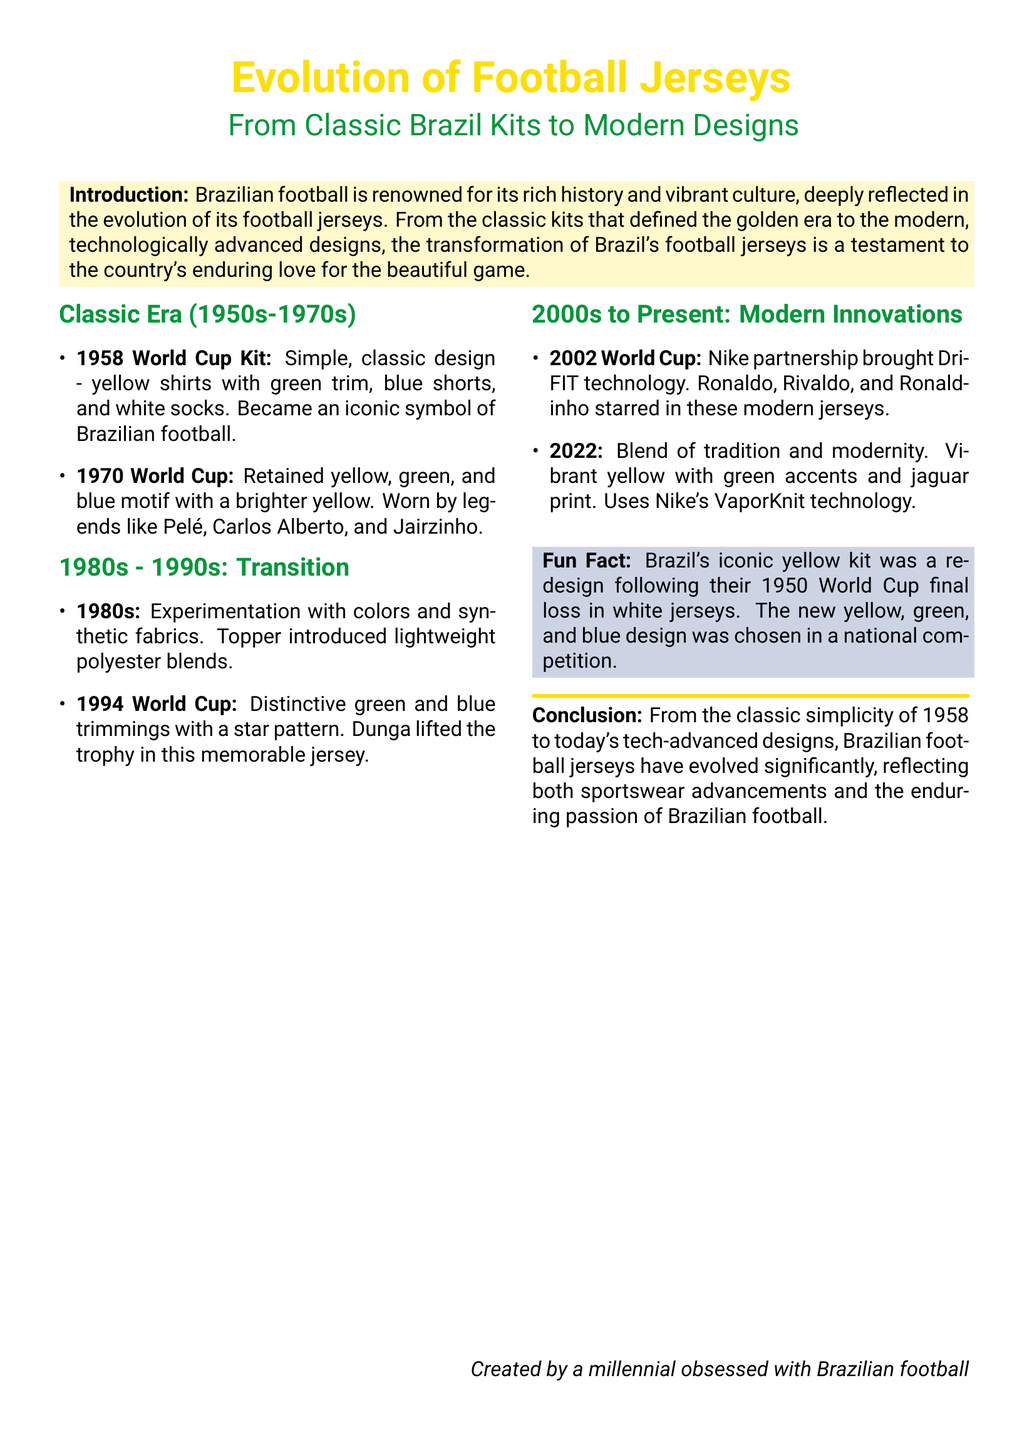what is the primary color of Brazil's iconic kit? The primary color of Brazil's iconic kit is yellow, reflecting its prominent use in their football jerseys since the 1950s.
Answer: yellow which decade saw the introduction of synthetic fabrics in Brazil's football jerseys? The 1980s were marked by experimentation with colors and synthetic fabrics used in Brazil's football jerseys.
Answer: 1980s who were some legendary players that wore the 1970 World Cup kit? The 1970 World Cup kit was worn by famous players like Pelé, Carlos Alberto, and Jairzinho.
Answer: Pelé, Carlos Alberto, Jairzinho what technology was introduced in the 2002 World Cup jerseys? Dri-FIT technology was introduced in the Brazil jerseys for the 2002 World Cup, enhancing player performance.
Answer: Dri-FIT technology what was the design inspiration for Brazil's yellow kit? The yellow kit was a redesign chosen in a national competition following Brazil's loss in the 1950 World Cup final when they wore white jerseys.
Answer: national competition how many World Cups are mentioned in the document? The document mentions three World Cups: 1958, 1994, and 2002.
Answer: three which company partnered with Brazil's national team starting in the 2002 World Cup? Nike became the partnering company for Brazil's national team jerseys beginning in the 2002 World Cup.
Answer: Nike what print was featured in the 2022 jersey design? The vibrant 2022 jersey design featured a jaguar print, combining tradition with modernity.
Answer: jaguar print 